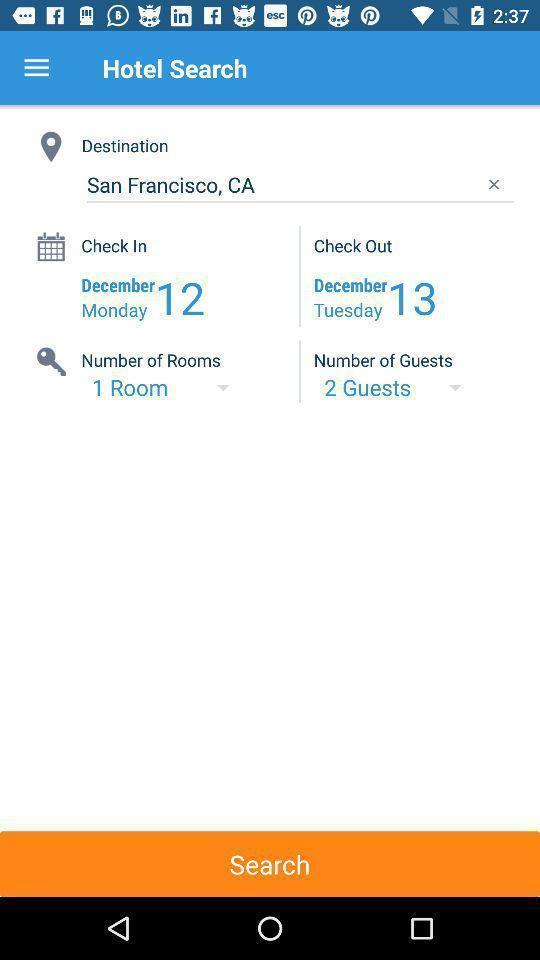Describe the visual elements of this screenshot. Screen displaying the hotel booking information. 